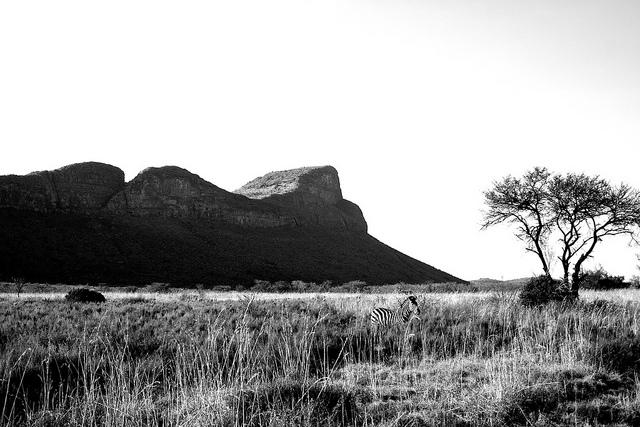Is this color or black and white?
Quick response, please. Black and white. How many trees can be seen?
Write a very short answer. 1. Do you see a zebra?
Quick response, please. Yes. 